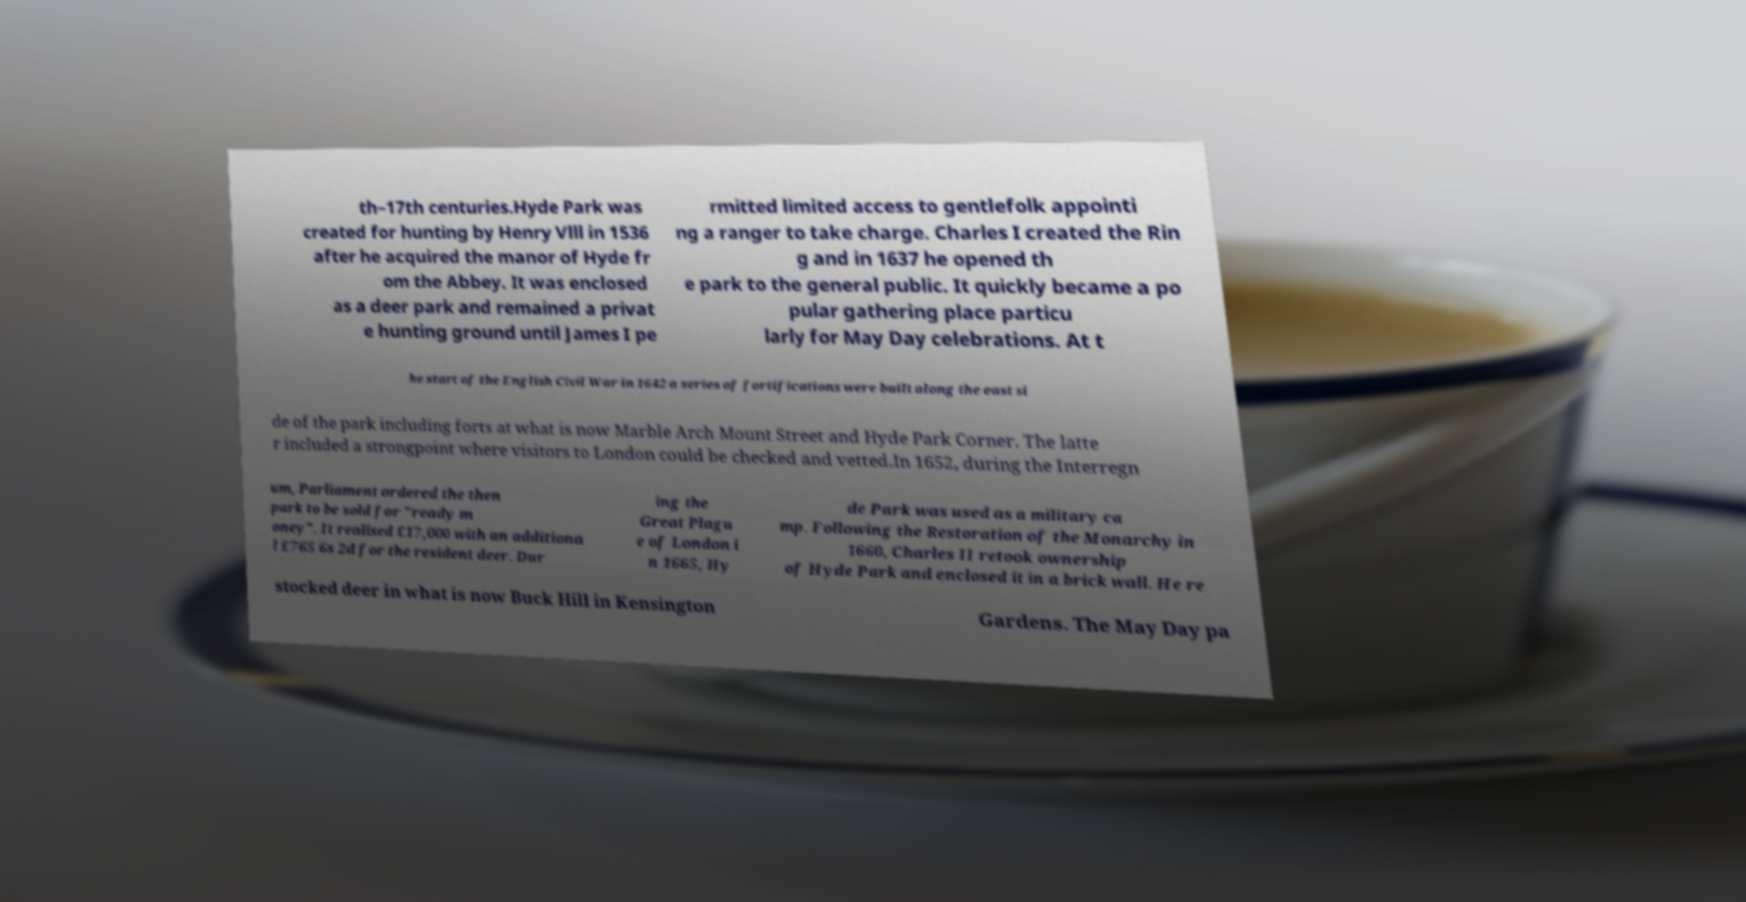What messages or text are displayed in this image? I need them in a readable, typed format. th–17th centuries.Hyde Park was created for hunting by Henry Vlll in 1536 after he acquired the manor of Hyde fr om the Abbey. It was enclosed as a deer park and remained a privat e hunting ground until James I pe rmitted limited access to gentlefolk appointi ng a ranger to take charge. Charles I created the Rin g and in 1637 he opened th e park to the general public. It quickly became a po pular gathering place particu larly for May Day celebrations. At t he start of the English Civil War in 1642 a series of fortifications were built along the east si de of the park including forts at what is now Marble Arch Mount Street and Hyde Park Corner. The latte r included a strongpoint where visitors to London could be checked and vetted.In 1652, during the Interregn um, Parliament ordered the then park to be sold for "ready m oney". It realised £17,000 with an additiona l £765 6s 2d for the resident deer. Dur ing the Great Plagu e of London i n 1665, Hy de Park was used as a military ca mp. Following the Restoration of the Monarchy in 1660, Charles II retook ownership of Hyde Park and enclosed it in a brick wall. He re stocked deer in what is now Buck Hill in Kensington Gardens. The May Day pa 